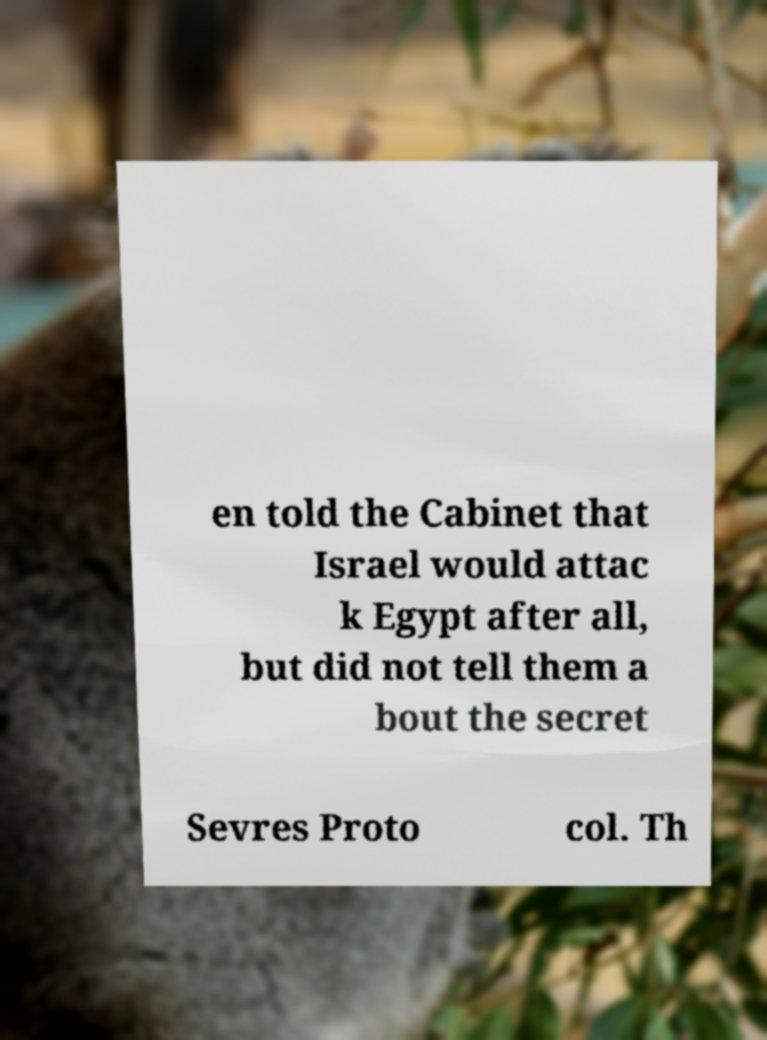Could you assist in decoding the text presented in this image and type it out clearly? en told the Cabinet that Israel would attac k Egypt after all, but did not tell them a bout the secret Sevres Proto col. Th 